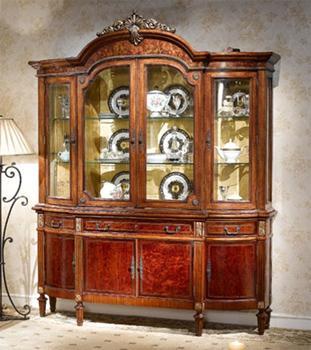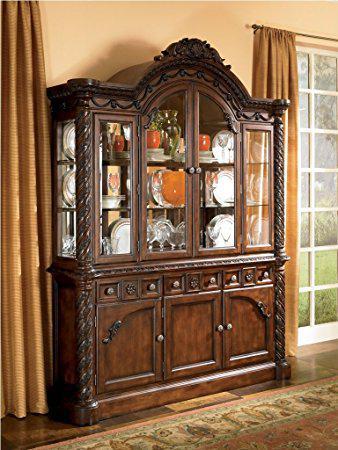The first image is the image on the left, the second image is the image on the right. Given the left and right images, does the statement "There is at least one hutch that is painted dark gray." hold true? Answer yes or no. No. The first image is the image on the left, the second image is the image on the right. Examine the images to the left and right. Is the description "The cabinet in the image on the left has an arch over the front center." accurate? Answer yes or no. Yes. 